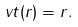<formula> <loc_0><loc_0><loc_500><loc_500>\ v t ( r ) = r .</formula> 